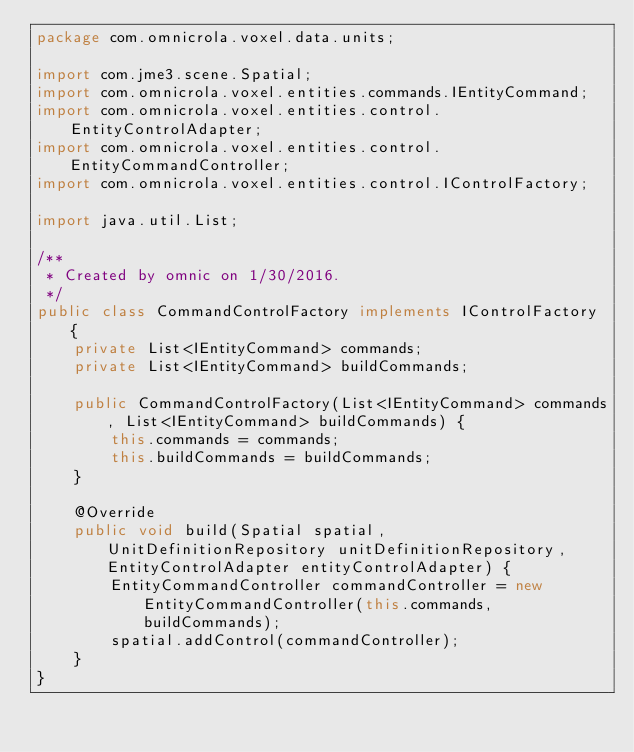<code> <loc_0><loc_0><loc_500><loc_500><_Java_>package com.omnicrola.voxel.data.units;

import com.jme3.scene.Spatial;
import com.omnicrola.voxel.entities.commands.IEntityCommand;
import com.omnicrola.voxel.entities.control.EntityControlAdapter;
import com.omnicrola.voxel.entities.control.EntityCommandController;
import com.omnicrola.voxel.entities.control.IControlFactory;

import java.util.List;

/**
 * Created by omnic on 1/30/2016.
 */
public class CommandControlFactory implements IControlFactory {
    private List<IEntityCommand> commands;
    private List<IEntityCommand> buildCommands;

    public CommandControlFactory(List<IEntityCommand> commands, List<IEntityCommand> buildCommands) {
        this.commands = commands;
        this.buildCommands = buildCommands;
    }

    @Override
    public void build(Spatial spatial, UnitDefinitionRepository unitDefinitionRepository, EntityControlAdapter entityControlAdapter) {
        EntityCommandController commandController = new EntityCommandController(this.commands, buildCommands);
        spatial.addControl(commandController);
    }
}
</code> 